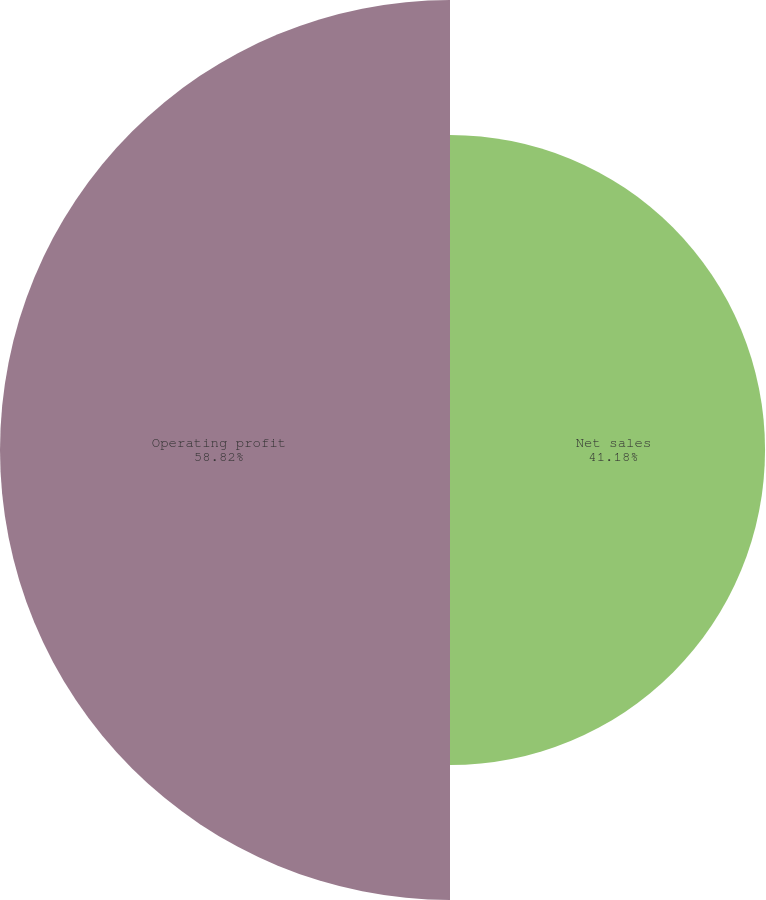Convert chart to OTSL. <chart><loc_0><loc_0><loc_500><loc_500><pie_chart><fcel>Net sales<fcel>Operating profit<nl><fcel>41.18%<fcel>58.82%<nl></chart> 